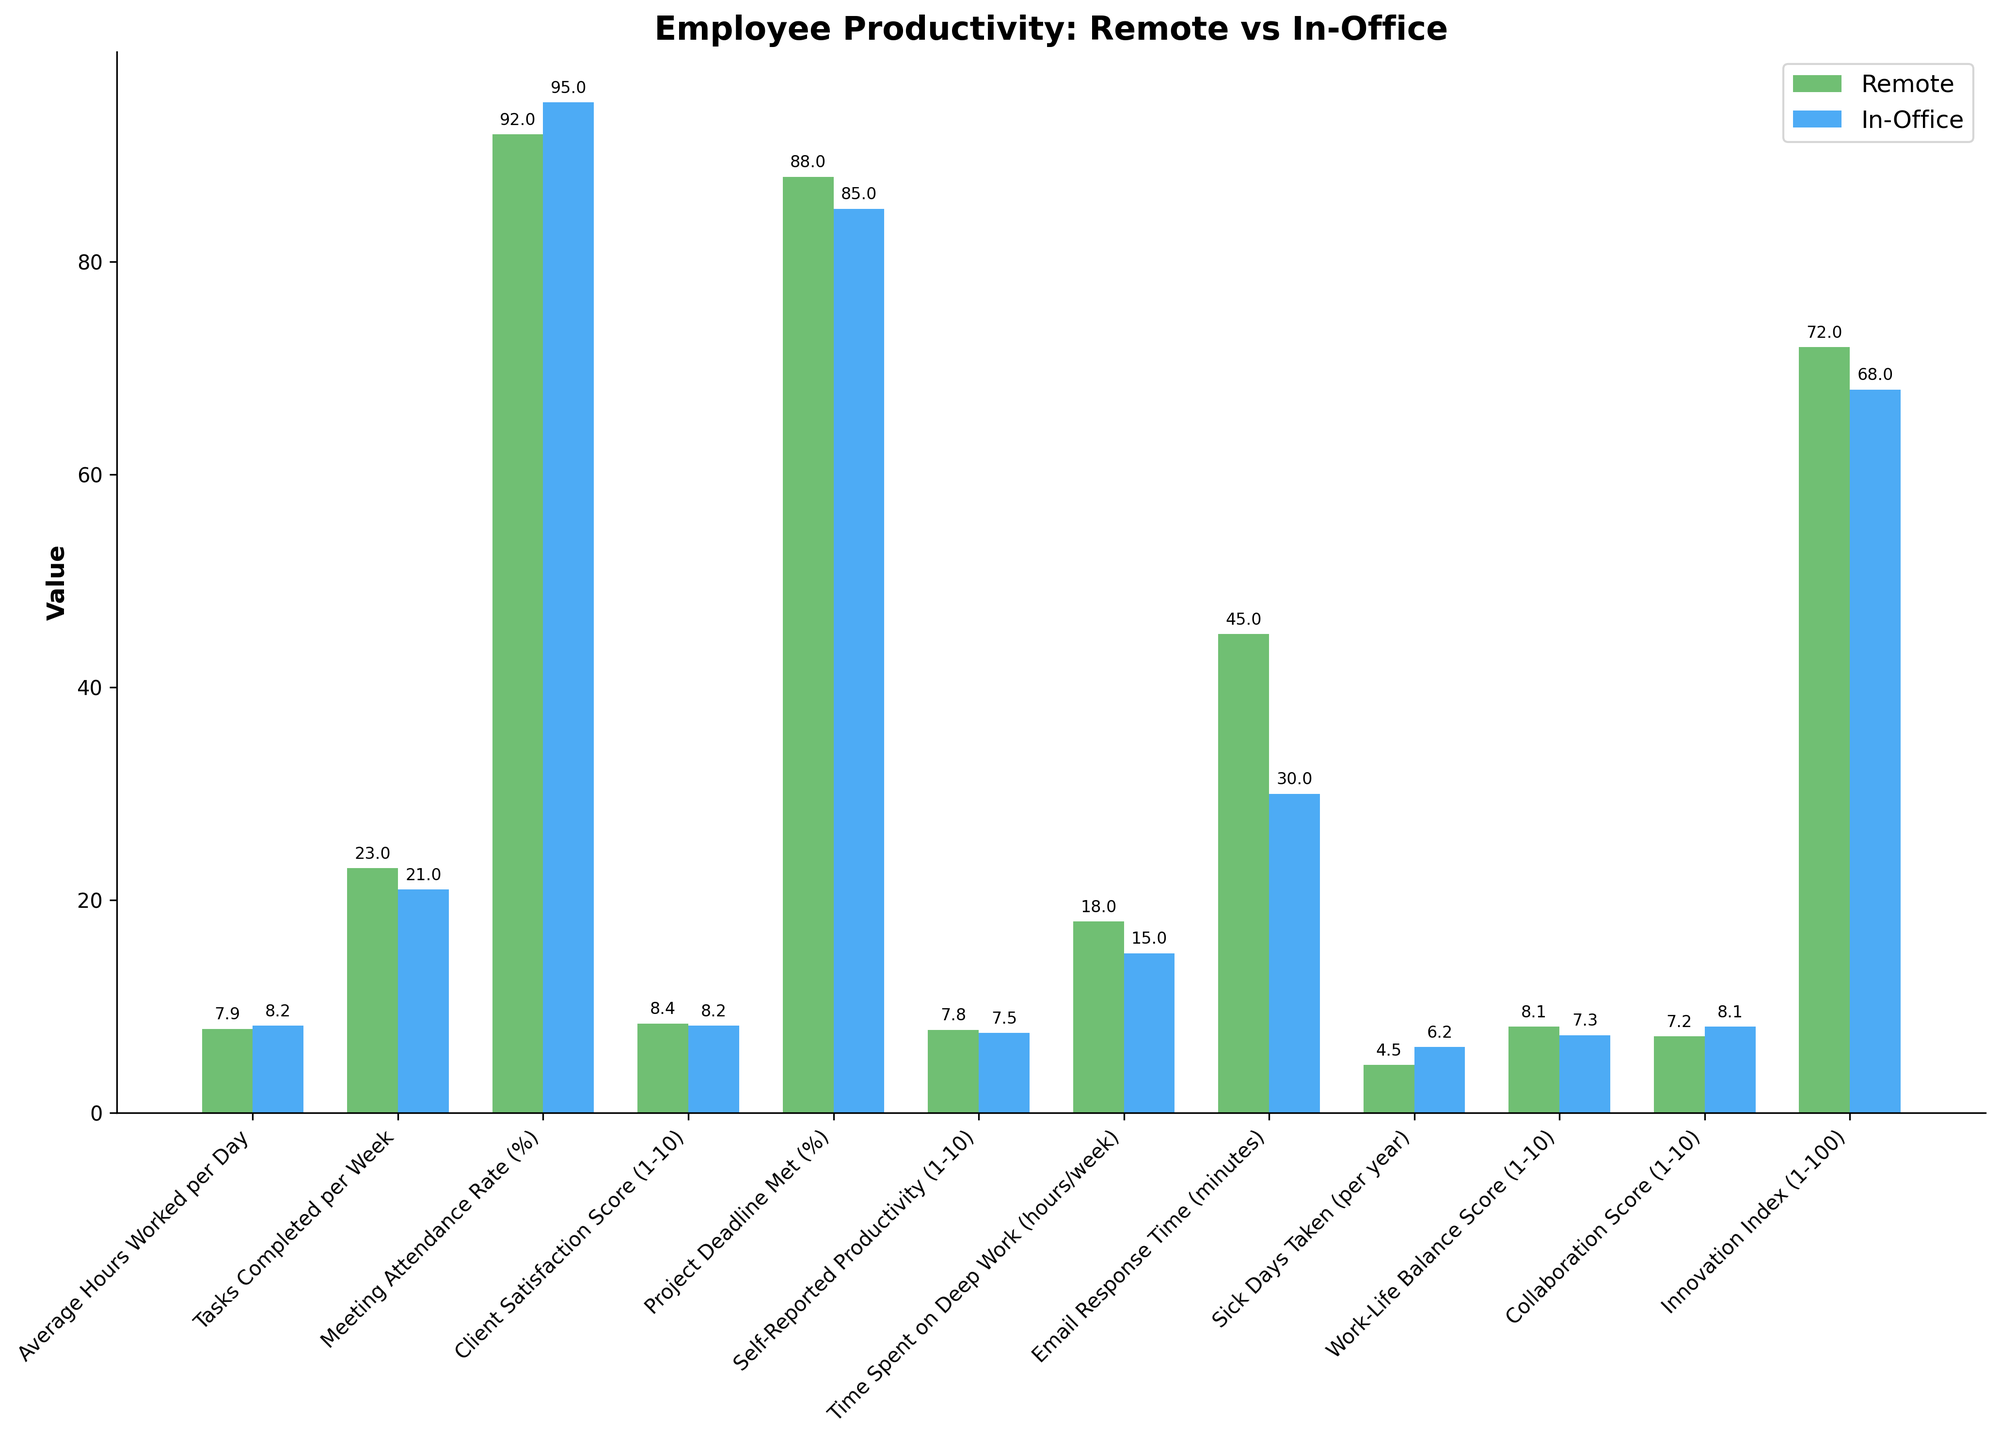What is the difference in average hours worked per day between remote and in-office employees? The figure shows the "Average Hours Worked per Day" for both remote and in-office settings. Remote employees work 7.9 hours per day on average, while in-office employees work 8.2 hours per day on average. The difference is 8.2 - 7.9 = 0.3 hours.
Answer: 0.3 hours Which work arrangement has a higher client satisfaction score? From the chart, the "Client Satisfaction Score" for remote work is 8.4, while for in-office work it is 8.2. Since 8.4 is greater than 8.2, remote work has a higher client satisfaction score.
Answer: Remote work How much more time do remote employees spend on deep work per week compared to in-office employees? The chart indicates that remote employees spend 18 hours on "Deep Work" per week, whereas in-office employees spend 15 hours. The difference is 18 - 15 = 3 hours.
Answer: 3 hours Which work setting has a lower email response time and by how much? In the chart, the "Email Response Time" for remote work is 45 minutes, while for in-office work it is 30 minutes. The difference is 45 - 30 = 15 minutes, so in-office work has a lower email response time by 15 minutes.
Answer: In-office work, 15 minutes What is the sum of the meeting attendance rate percentage for both remote and in-office employees? The "Meeting Attendance Rate" for remote employees is 92% and for in-office is 95%. The sum is 92 + 95 = 187%.
Answer: 187% Which category shows a higher value for in-office employees than remote employees in terms of collaboration score? The "Collaboration Score" for in-office employees is 8.1 and for remote employees is 7.2. Since 8.1 is greater than 7.2, in-office employees have a higher collaboration score.
Answer: In-office In which metric do remote employees significantly outperform in-office employees? Visualization of the chart shows that remote employees outperform in-office employees significantly in the "Time Spent on Deep Work" metric, with 18 hours compared to 15 hours.
Answer: Time Spent on Deep Work Is the self-reported productivity higher in remote or in-office work arrangements? According to the figure, the "Self-Reported Productivity" is 7.8 for remote work and 7.5 for in-office work. Remote work has the higher value.
Answer: Remote work Which work arrangement has more sick days taken per year, and what is the difference? The "Sick Days Taken" metric shows 4.5 days for remote and 6.2 days for in-office. The difference is 6.2 - 4.5 = 1.7 days, with in-office workers taking more sick days.
Answer: In-office, 1.7 days What is the difference between the innovation index for remote and in-office work settings? The "Innovation Index" is 72 for remote and 68 for in-office. The difference is 72 - 68 = 4.
Answer: 4 